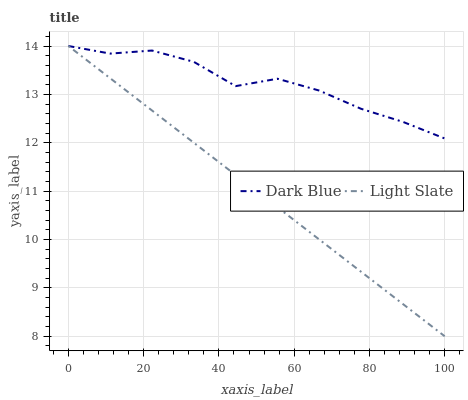Does Light Slate have the minimum area under the curve?
Answer yes or no. Yes. Does Dark Blue have the maximum area under the curve?
Answer yes or no. Yes. Does Dark Blue have the minimum area under the curve?
Answer yes or no. No. Is Light Slate the smoothest?
Answer yes or no. Yes. Is Dark Blue the roughest?
Answer yes or no. Yes. Is Dark Blue the smoothest?
Answer yes or no. No. Does Light Slate have the lowest value?
Answer yes or no. Yes. Does Dark Blue have the lowest value?
Answer yes or no. No. Does Dark Blue have the highest value?
Answer yes or no. Yes. Does Light Slate intersect Dark Blue?
Answer yes or no. Yes. Is Light Slate less than Dark Blue?
Answer yes or no. No. Is Light Slate greater than Dark Blue?
Answer yes or no. No. 